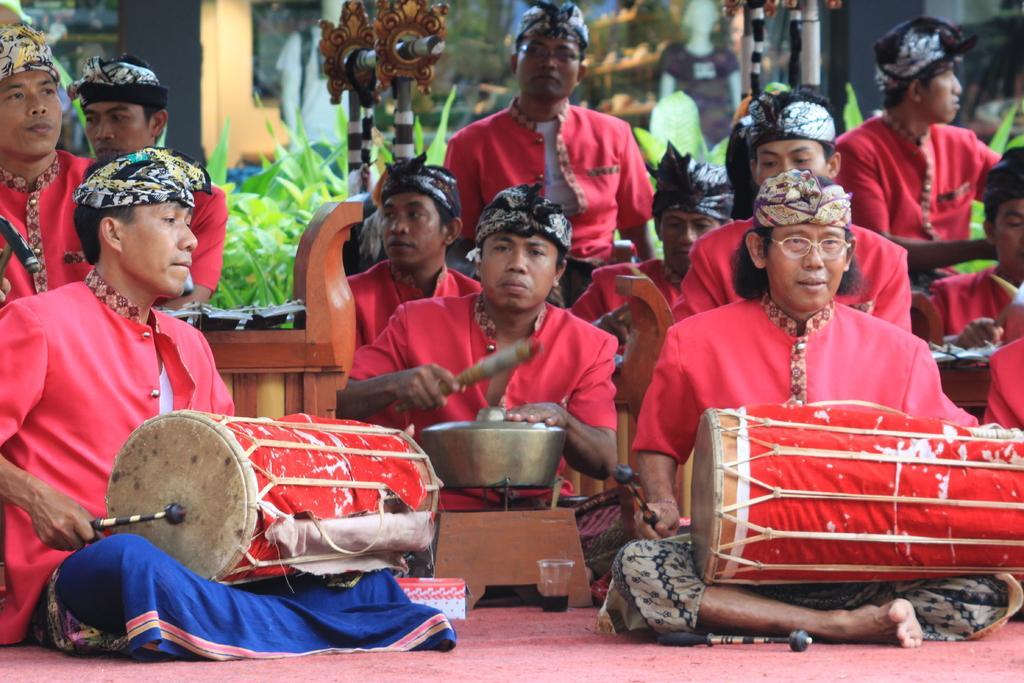Can you describe this image briefly? In the image, there are lot of people sitting and playing drums, they are wearing red color costume, in the background there is a wooden a chair, behind it there are some trees. 